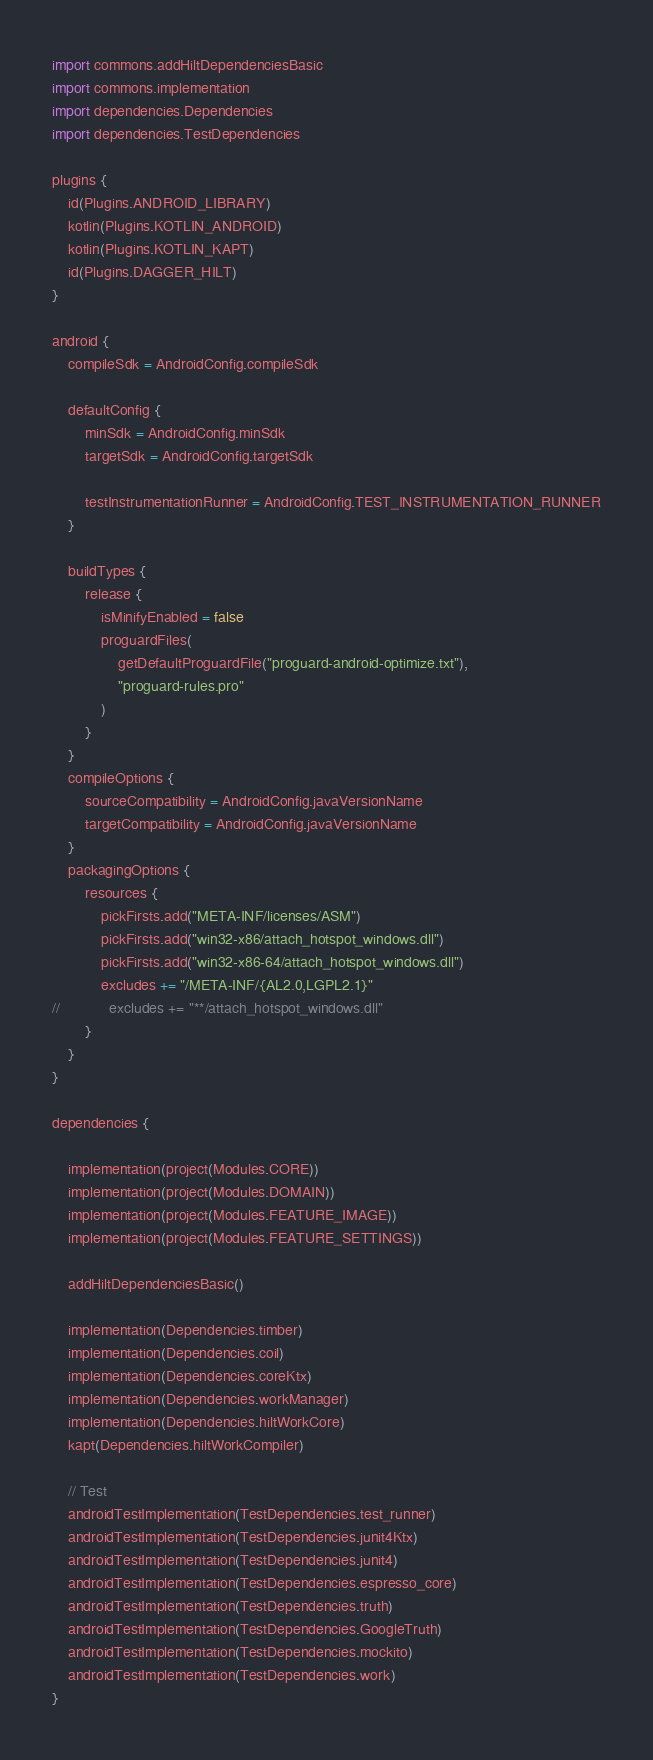Convert code to text. <code><loc_0><loc_0><loc_500><loc_500><_Kotlin_>import commons.addHiltDependenciesBasic
import commons.implementation
import dependencies.Dependencies
import dependencies.TestDependencies

plugins {
    id(Plugins.ANDROID_LIBRARY)
    kotlin(Plugins.KOTLIN_ANDROID)
    kotlin(Plugins.KOTLIN_KAPT)
    id(Plugins.DAGGER_HILT)
}

android {
    compileSdk = AndroidConfig.compileSdk

    defaultConfig {
        minSdk = AndroidConfig.minSdk
        targetSdk = AndroidConfig.targetSdk

        testInstrumentationRunner = AndroidConfig.TEST_INSTRUMENTATION_RUNNER
    }

    buildTypes {
        release {
            isMinifyEnabled = false
            proguardFiles(
                getDefaultProguardFile("proguard-android-optimize.txt"),
                "proguard-rules.pro"
            )
        }
    }
    compileOptions {
        sourceCompatibility = AndroidConfig.javaVersionName
        targetCompatibility = AndroidConfig.javaVersionName
    }
    packagingOptions {
        resources {
            pickFirsts.add("META-INF/licenses/ASM")
            pickFirsts.add("win32-x86/attach_hotspot_windows.dll")
            pickFirsts.add("win32-x86-64/attach_hotspot_windows.dll")
            excludes += "/META-INF/{AL2.0,LGPL2.1}"
//            excludes += "**/attach_hotspot_windows.dll"
        }
    }
}

dependencies {

    implementation(project(Modules.CORE))
    implementation(project(Modules.DOMAIN))
    implementation(project(Modules.FEATURE_IMAGE))
    implementation(project(Modules.FEATURE_SETTINGS))

    addHiltDependenciesBasic()

    implementation(Dependencies.timber)
    implementation(Dependencies.coil)
    implementation(Dependencies.coreKtx)
    implementation(Dependencies.workManager)
    implementation(Dependencies.hiltWorkCore)
    kapt(Dependencies.hiltWorkCompiler)

    // Test
    androidTestImplementation(TestDependencies.test_runner)
    androidTestImplementation(TestDependencies.junit4Ktx)
    androidTestImplementation(TestDependencies.junit4)
    androidTestImplementation(TestDependencies.espresso_core)
    androidTestImplementation(TestDependencies.truth)
    androidTestImplementation(TestDependencies.GoogleTruth)
    androidTestImplementation(TestDependencies.mockito)
    androidTestImplementation(TestDependencies.work)
}</code> 